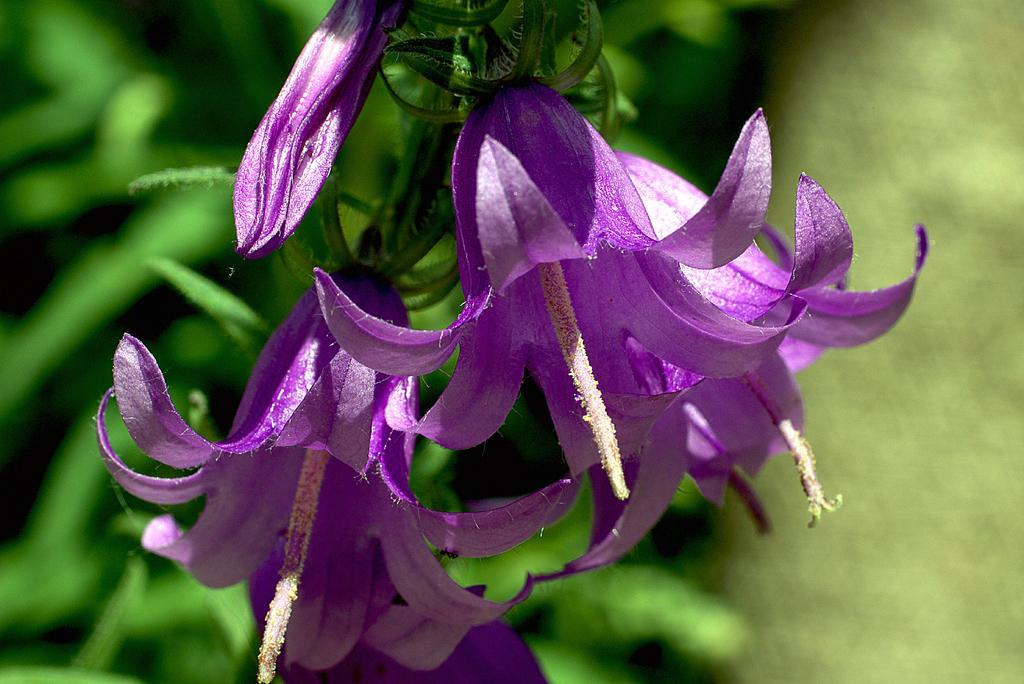What type of plants can be seen in the image? There are flowers in the image. What color are the flowers? The flowers are purple. What else can be seen in the background of the image? There are leaves in the background of the image. What type of boats can be seen in the image? There are no boats present in the image; it features flowers and leaves. Is there a collar visible on any of the flowers in the image? There is no collar present on the flowers in the image; they are simply flowers with leaves in the background. 